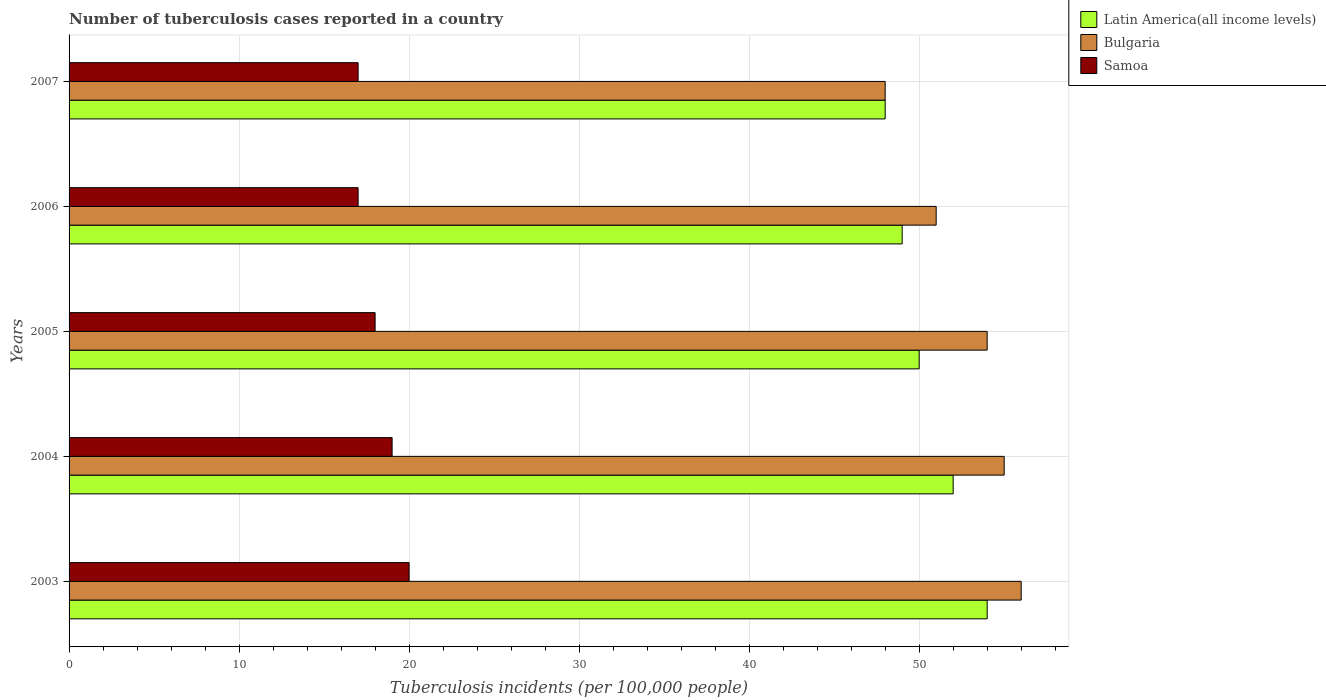How many groups of bars are there?
Keep it short and to the point. 5. What is the label of the 5th group of bars from the top?
Offer a very short reply. 2003. In how many cases, is the number of bars for a given year not equal to the number of legend labels?
Your answer should be compact. 0. What is the number of tuberculosis cases reported in in Samoa in 2006?
Your answer should be very brief. 17. Across all years, what is the maximum number of tuberculosis cases reported in in Samoa?
Your answer should be very brief. 20. Across all years, what is the minimum number of tuberculosis cases reported in in Latin America(all income levels)?
Offer a very short reply. 48. In which year was the number of tuberculosis cases reported in in Latin America(all income levels) maximum?
Your answer should be compact. 2003. What is the total number of tuberculosis cases reported in in Latin America(all income levels) in the graph?
Keep it short and to the point. 253. What is the difference between the number of tuberculosis cases reported in in Latin America(all income levels) in 2004 and that in 2007?
Your answer should be very brief. 4. What is the difference between the number of tuberculosis cases reported in in Latin America(all income levels) in 2005 and the number of tuberculosis cases reported in in Bulgaria in 2003?
Keep it short and to the point. -6. What is the average number of tuberculosis cases reported in in Latin America(all income levels) per year?
Make the answer very short. 50.6. In the year 2006, what is the difference between the number of tuberculosis cases reported in in Bulgaria and number of tuberculosis cases reported in in Latin America(all income levels)?
Keep it short and to the point. 2. In how many years, is the number of tuberculosis cases reported in in Latin America(all income levels) greater than 46 ?
Offer a terse response. 5. What is the ratio of the number of tuberculosis cases reported in in Latin America(all income levels) in 2003 to that in 2004?
Offer a very short reply. 1.04. Is the number of tuberculosis cases reported in in Samoa in 2004 less than that in 2005?
Keep it short and to the point. No. What is the difference between the highest and the second highest number of tuberculosis cases reported in in Latin America(all income levels)?
Keep it short and to the point. 2. In how many years, is the number of tuberculosis cases reported in in Samoa greater than the average number of tuberculosis cases reported in in Samoa taken over all years?
Offer a very short reply. 2. Is the sum of the number of tuberculosis cases reported in in Samoa in 2004 and 2006 greater than the maximum number of tuberculosis cases reported in in Latin America(all income levels) across all years?
Your answer should be compact. No. What does the 2nd bar from the top in 2005 represents?
Provide a succinct answer. Bulgaria. Is it the case that in every year, the sum of the number of tuberculosis cases reported in in Bulgaria and number of tuberculosis cases reported in in Latin America(all income levels) is greater than the number of tuberculosis cases reported in in Samoa?
Your answer should be very brief. Yes. Are all the bars in the graph horizontal?
Provide a short and direct response. Yes. What is the difference between two consecutive major ticks on the X-axis?
Give a very brief answer. 10. Does the graph contain any zero values?
Provide a succinct answer. No. Where does the legend appear in the graph?
Give a very brief answer. Top right. What is the title of the graph?
Provide a succinct answer. Number of tuberculosis cases reported in a country. Does "Sao Tome and Principe" appear as one of the legend labels in the graph?
Keep it short and to the point. No. What is the label or title of the X-axis?
Make the answer very short. Tuberculosis incidents (per 100,0 people). What is the label or title of the Y-axis?
Provide a short and direct response. Years. What is the Tuberculosis incidents (per 100,000 people) in Latin America(all income levels) in 2003?
Keep it short and to the point. 54. What is the Tuberculosis incidents (per 100,000 people) in Bulgaria in 2003?
Keep it short and to the point. 56. What is the Tuberculosis incidents (per 100,000 people) of Samoa in 2003?
Ensure brevity in your answer.  20. What is the Tuberculosis incidents (per 100,000 people) in Latin America(all income levels) in 2004?
Make the answer very short. 52. What is the Tuberculosis incidents (per 100,000 people) of Bulgaria in 2005?
Ensure brevity in your answer.  54. What is the Tuberculosis incidents (per 100,000 people) in Samoa in 2005?
Offer a terse response. 18. Across all years, what is the maximum Tuberculosis incidents (per 100,000 people) of Samoa?
Provide a short and direct response. 20. Across all years, what is the minimum Tuberculosis incidents (per 100,000 people) in Latin America(all income levels)?
Provide a short and direct response. 48. What is the total Tuberculosis incidents (per 100,000 people) in Latin America(all income levels) in the graph?
Provide a short and direct response. 253. What is the total Tuberculosis incidents (per 100,000 people) of Bulgaria in the graph?
Make the answer very short. 264. What is the total Tuberculosis incidents (per 100,000 people) of Samoa in the graph?
Ensure brevity in your answer.  91. What is the difference between the Tuberculosis incidents (per 100,000 people) in Latin America(all income levels) in 2003 and that in 2004?
Your answer should be compact. 2. What is the difference between the Tuberculosis incidents (per 100,000 people) of Bulgaria in 2003 and that in 2004?
Your response must be concise. 1. What is the difference between the Tuberculosis incidents (per 100,000 people) in Bulgaria in 2003 and that in 2005?
Provide a succinct answer. 2. What is the difference between the Tuberculosis incidents (per 100,000 people) in Latin America(all income levels) in 2003 and that in 2006?
Your response must be concise. 5. What is the difference between the Tuberculosis incidents (per 100,000 people) in Samoa in 2003 and that in 2006?
Provide a short and direct response. 3. What is the difference between the Tuberculosis incidents (per 100,000 people) in Latin America(all income levels) in 2003 and that in 2007?
Offer a very short reply. 6. What is the difference between the Tuberculosis incidents (per 100,000 people) in Bulgaria in 2004 and that in 2005?
Ensure brevity in your answer.  1. What is the difference between the Tuberculosis incidents (per 100,000 people) in Samoa in 2004 and that in 2005?
Keep it short and to the point. 1. What is the difference between the Tuberculosis incidents (per 100,000 people) of Latin America(all income levels) in 2004 and that in 2006?
Your response must be concise. 3. What is the difference between the Tuberculosis incidents (per 100,000 people) in Latin America(all income levels) in 2004 and that in 2007?
Offer a terse response. 4. What is the difference between the Tuberculosis incidents (per 100,000 people) of Latin America(all income levels) in 2005 and that in 2006?
Ensure brevity in your answer.  1. What is the difference between the Tuberculosis incidents (per 100,000 people) in Bulgaria in 2005 and that in 2007?
Ensure brevity in your answer.  6. What is the difference between the Tuberculosis incidents (per 100,000 people) of Bulgaria in 2006 and that in 2007?
Give a very brief answer. 3. What is the difference between the Tuberculosis incidents (per 100,000 people) in Latin America(all income levels) in 2003 and the Tuberculosis incidents (per 100,000 people) in Bulgaria in 2004?
Offer a terse response. -1. What is the difference between the Tuberculosis incidents (per 100,000 people) of Latin America(all income levels) in 2003 and the Tuberculosis incidents (per 100,000 people) of Samoa in 2004?
Offer a terse response. 35. What is the difference between the Tuberculosis incidents (per 100,000 people) in Bulgaria in 2003 and the Tuberculosis incidents (per 100,000 people) in Samoa in 2005?
Keep it short and to the point. 38. What is the difference between the Tuberculosis incidents (per 100,000 people) in Latin America(all income levels) in 2003 and the Tuberculosis incidents (per 100,000 people) in Samoa in 2006?
Ensure brevity in your answer.  37. What is the difference between the Tuberculosis incidents (per 100,000 people) of Latin America(all income levels) in 2004 and the Tuberculosis incidents (per 100,000 people) of Bulgaria in 2005?
Offer a terse response. -2. What is the difference between the Tuberculosis incidents (per 100,000 people) in Latin America(all income levels) in 2004 and the Tuberculosis incidents (per 100,000 people) in Samoa in 2005?
Your answer should be compact. 34. What is the difference between the Tuberculosis incidents (per 100,000 people) of Latin America(all income levels) in 2004 and the Tuberculosis incidents (per 100,000 people) of Bulgaria in 2007?
Your answer should be very brief. 4. What is the difference between the Tuberculosis incidents (per 100,000 people) of Bulgaria in 2005 and the Tuberculosis incidents (per 100,000 people) of Samoa in 2006?
Make the answer very short. 37. What is the difference between the Tuberculosis incidents (per 100,000 people) of Latin America(all income levels) in 2005 and the Tuberculosis incidents (per 100,000 people) of Bulgaria in 2007?
Give a very brief answer. 2. What is the difference between the Tuberculosis incidents (per 100,000 people) of Latin America(all income levels) in 2005 and the Tuberculosis incidents (per 100,000 people) of Samoa in 2007?
Keep it short and to the point. 33. What is the difference between the Tuberculosis incidents (per 100,000 people) in Bulgaria in 2005 and the Tuberculosis incidents (per 100,000 people) in Samoa in 2007?
Provide a short and direct response. 37. What is the difference between the Tuberculosis incidents (per 100,000 people) of Latin America(all income levels) in 2006 and the Tuberculosis incidents (per 100,000 people) of Bulgaria in 2007?
Offer a very short reply. 1. What is the difference between the Tuberculosis incidents (per 100,000 people) in Bulgaria in 2006 and the Tuberculosis incidents (per 100,000 people) in Samoa in 2007?
Ensure brevity in your answer.  34. What is the average Tuberculosis incidents (per 100,000 people) in Latin America(all income levels) per year?
Provide a succinct answer. 50.6. What is the average Tuberculosis incidents (per 100,000 people) in Bulgaria per year?
Keep it short and to the point. 52.8. What is the average Tuberculosis incidents (per 100,000 people) in Samoa per year?
Offer a terse response. 18.2. In the year 2004, what is the difference between the Tuberculosis incidents (per 100,000 people) in Latin America(all income levels) and Tuberculosis incidents (per 100,000 people) in Bulgaria?
Ensure brevity in your answer.  -3. In the year 2004, what is the difference between the Tuberculosis incidents (per 100,000 people) in Bulgaria and Tuberculosis incidents (per 100,000 people) in Samoa?
Provide a short and direct response. 36. In the year 2005, what is the difference between the Tuberculosis incidents (per 100,000 people) in Latin America(all income levels) and Tuberculosis incidents (per 100,000 people) in Bulgaria?
Keep it short and to the point. -4. In the year 2005, what is the difference between the Tuberculosis incidents (per 100,000 people) in Latin America(all income levels) and Tuberculosis incidents (per 100,000 people) in Samoa?
Provide a short and direct response. 32. In the year 2005, what is the difference between the Tuberculosis incidents (per 100,000 people) of Bulgaria and Tuberculosis incidents (per 100,000 people) of Samoa?
Offer a terse response. 36. In the year 2006, what is the difference between the Tuberculosis incidents (per 100,000 people) of Latin America(all income levels) and Tuberculosis incidents (per 100,000 people) of Samoa?
Provide a succinct answer. 32. In the year 2006, what is the difference between the Tuberculosis incidents (per 100,000 people) in Bulgaria and Tuberculosis incidents (per 100,000 people) in Samoa?
Provide a short and direct response. 34. In the year 2007, what is the difference between the Tuberculosis incidents (per 100,000 people) in Latin America(all income levels) and Tuberculosis incidents (per 100,000 people) in Bulgaria?
Your answer should be compact. 0. In the year 2007, what is the difference between the Tuberculosis incidents (per 100,000 people) of Latin America(all income levels) and Tuberculosis incidents (per 100,000 people) of Samoa?
Give a very brief answer. 31. In the year 2007, what is the difference between the Tuberculosis incidents (per 100,000 people) of Bulgaria and Tuberculosis incidents (per 100,000 people) of Samoa?
Offer a very short reply. 31. What is the ratio of the Tuberculosis incidents (per 100,000 people) in Latin America(all income levels) in 2003 to that in 2004?
Keep it short and to the point. 1.04. What is the ratio of the Tuberculosis incidents (per 100,000 people) of Bulgaria in 2003 to that in 2004?
Give a very brief answer. 1.02. What is the ratio of the Tuberculosis incidents (per 100,000 people) in Samoa in 2003 to that in 2004?
Your answer should be very brief. 1.05. What is the ratio of the Tuberculosis incidents (per 100,000 people) in Bulgaria in 2003 to that in 2005?
Provide a succinct answer. 1.04. What is the ratio of the Tuberculosis incidents (per 100,000 people) in Samoa in 2003 to that in 2005?
Ensure brevity in your answer.  1.11. What is the ratio of the Tuberculosis incidents (per 100,000 people) of Latin America(all income levels) in 2003 to that in 2006?
Give a very brief answer. 1.1. What is the ratio of the Tuberculosis incidents (per 100,000 people) in Bulgaria in 2003 to that in 2006?
Offer a very short reply. 1.1. What is the ratio of the Tuberculosis incidents (per 100,000 people) of Samoa in 2003 to that in 2006?
Your response must be concise. 1.18. What is the ratio of the Tuberculosis incidents (per 100,000 people) in Bulgaria in 2003 to that in 2007?
Keep it short and to the point. 1.17. What is the ratio of the Tuberculosis incidents (per 100,000 people) of Samoa in 2003 to that in 2007?
Provide a short and direct response. 1.18. What is the ratio of the Tuberculosis incidents (per 100,000 people) in Latin America(all income levels) in 2004 to that in 2005?
Offer a very short reply. 1.04. What is the ratio of the Tuberculosis incidents (per 100,000 people) of Bulgaria in 2004 to that in 2005?
Your answer should be very brief. 1.02. What is the ratio of the Tuberculosis incidents (per 100,000 people) in Samoa in 2004 to that in 2005?
Your answer should be very brief. 1.06. What is the ratio of the Tuberculosis incidents (per 100,000 people) in Latin America(all income levels) in 2004 to that in 2006?
Offer a very short reply. 1.06. What is the ratio of the Tuberculosis incidents (per 100,000 people) in Bulgaria in 2004 to that in 2006?
Your answer should be compact. 1.08. What is the ratio of the Tuberculosis incidents (per 100,000 people) in Samoa in 2004 to that in 2006?
Provide a short and direct response. 1.12. What is the ratio of the Tuberculosis incidents (per 100,000 people) of Latin America(all income levels) in 2004 to that in 2007?
Your response must be concise. 1.08. What is the ratio of the Tuberculosis incidents (per 100,000 people) in Bulgaria in 2004 to that in 2007?
Offer a very short reply. 1.15. What is the ratio of the Tuberculosis incidents (per 100,000 people) of Samoa in 2004 to that in 2007?
Ensure brevity in your answer.  1.12. What is the ratio of the Tuberculosis incidents (per 100,000 people) in Latin America(all income levels) in 2005 to that in 2006?
Give a very brief answer. 1.02. What is the ratio of the Tuberculosis incidents (per 100,000 people) of Bulgaria in 2005 to that in 2006?
Ensure brevity in your answer.  1.06. What is the ratio of the Tuberculosis incidents (per 100,000 people) in Samoa in 2005 to that in 2006?
Provide a succinct answer. 1.06. What is the ratio of the Tuberculosis incidents (per 100,000 people) in Latin America(all income levels) in 2005 to that in 2007?
Give a very brief answer. 1.04. What is the ratio of the Tuberculosis incidents (per 100,000 people) of Samoa in 2005 to that in 2007?
Keep it short and to the point. 1.06. What is the ratio of the Tuberculosis incidents (per 100,000 people) of Latin America(all income levels) in 2006 to that in 2007?
Offer a very short reply. 1.02. What is the difference between the highest and the lowest Tuberculosis incidents (per 100,000 people) in Bulgaria?
Give a very brief answer. 8. 